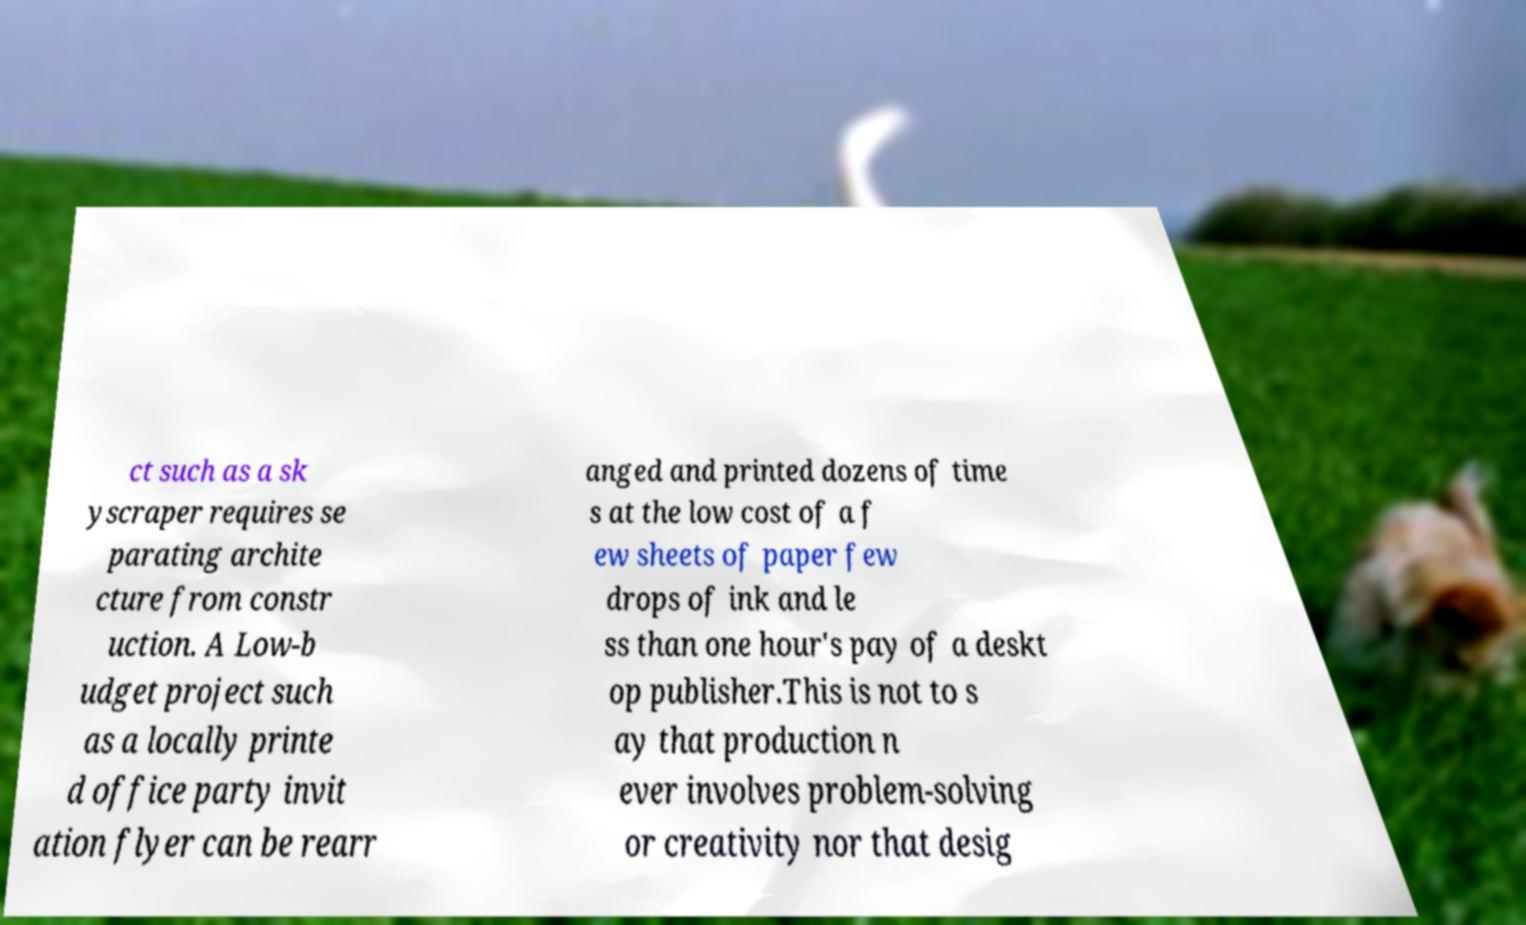Could you assist in decoding the text presented in this image and type it out clearly? ct such as a sk yscraper requires se parating archite cture from constr uction. A Low-b udget project such as a locally printe d office party invit ation flyer can be rearr anged and printed dozens of time s at the low cost of a f ew sheets of paper few drops of ink and le ss than one hour's pay of a deskt op publisher.This is not to s ay that production n ever involves problem-solving or creativity nor that desig 